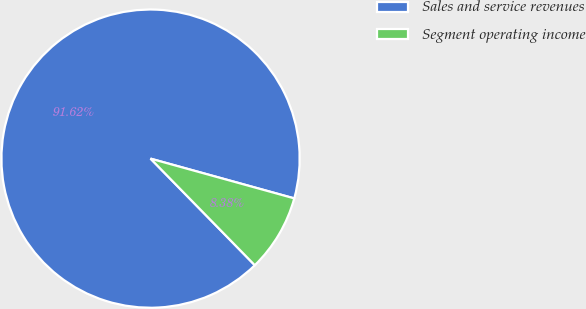Convert chart. <chart><loc_0><loc_0><loc_500><loc_500><pie_chart><fcel>Sales and service revenues<fcel>Segment operating income<nl><fcel>91.62%<fcel>8.38%<nl></chart> 